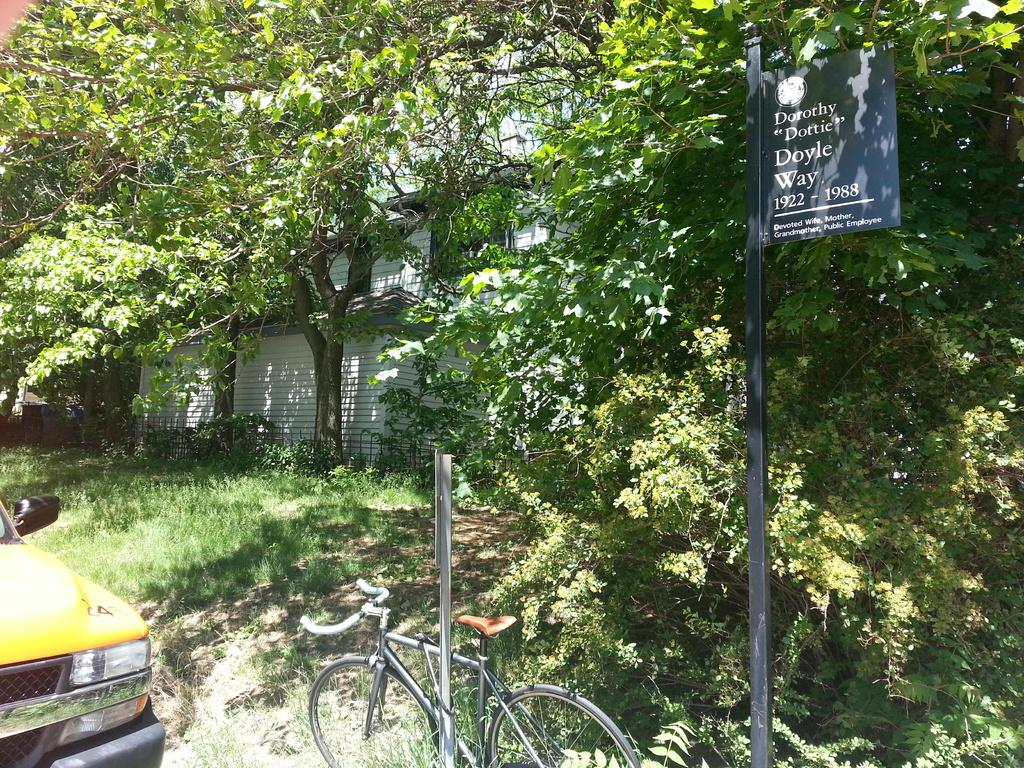What type of vehicle is in the image? There is a vehicle in the image, but the specific type is not mentioned. What other mode of transportation is present in the image? There is a bicycle in the image. What structures can be seen in the image? There are poles and a board in the image. What type of vegetation is visible in the image? There are trees, plants, and grass in the image. What type of building is in the image? There is a building in the image, but the specific type is not mentioned. What type of oil is being used to lubricate the wheel in the image? There is no wheel or mention of oil in the image. How does the destruction of the building affect the image? There is no destruction or damage to the building in the image. 